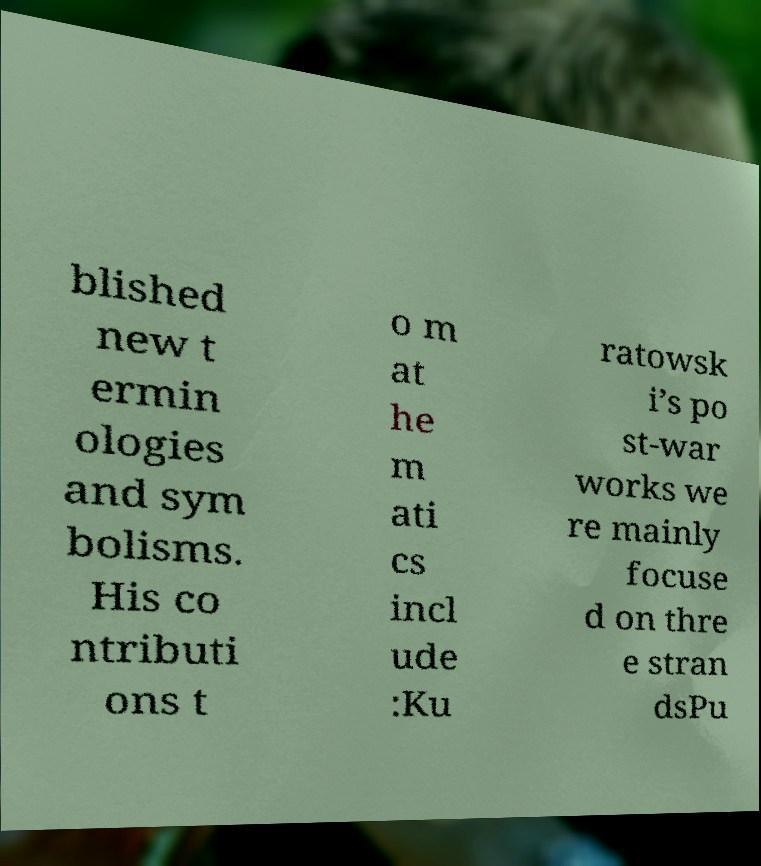For documentation purposes, I need the text within this image transcribed. Could you provide that? blished new t ermin ologies and sym bolisms. His co ntributi ons t o m at he m ati cs incl ude :Ku ratowsk i’s po st-war works we re mainly focuse d on thre e stran dsPu 